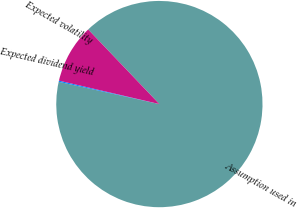Convert chart to OTSL. <chart><loc_0><loc_0><loc_500><loc_500><pie_chart><fcel>Assumption used in<fcel>Expected dividend yield<fcel>Expected volatility<nl><fcel>90.59%<fcel>0.18%<fcel>9.22%<nl></chart> 